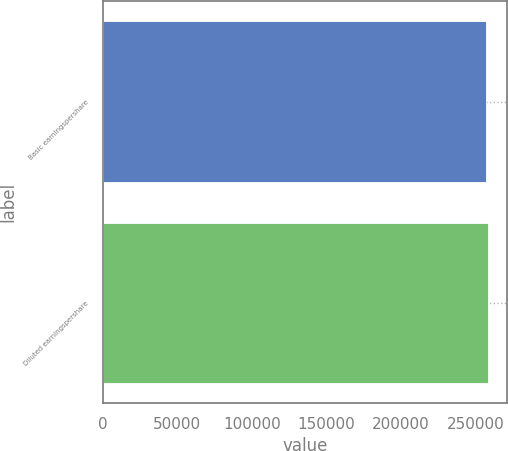Convert chart to OTSL. <chart><loc_0><loc_0><loc_500><loc_500><bar_chart><fcel>Basic earningspershare<fcel>Diluted earningspershare<nl><fcel>256553<fcel>258053<nl></chart> 